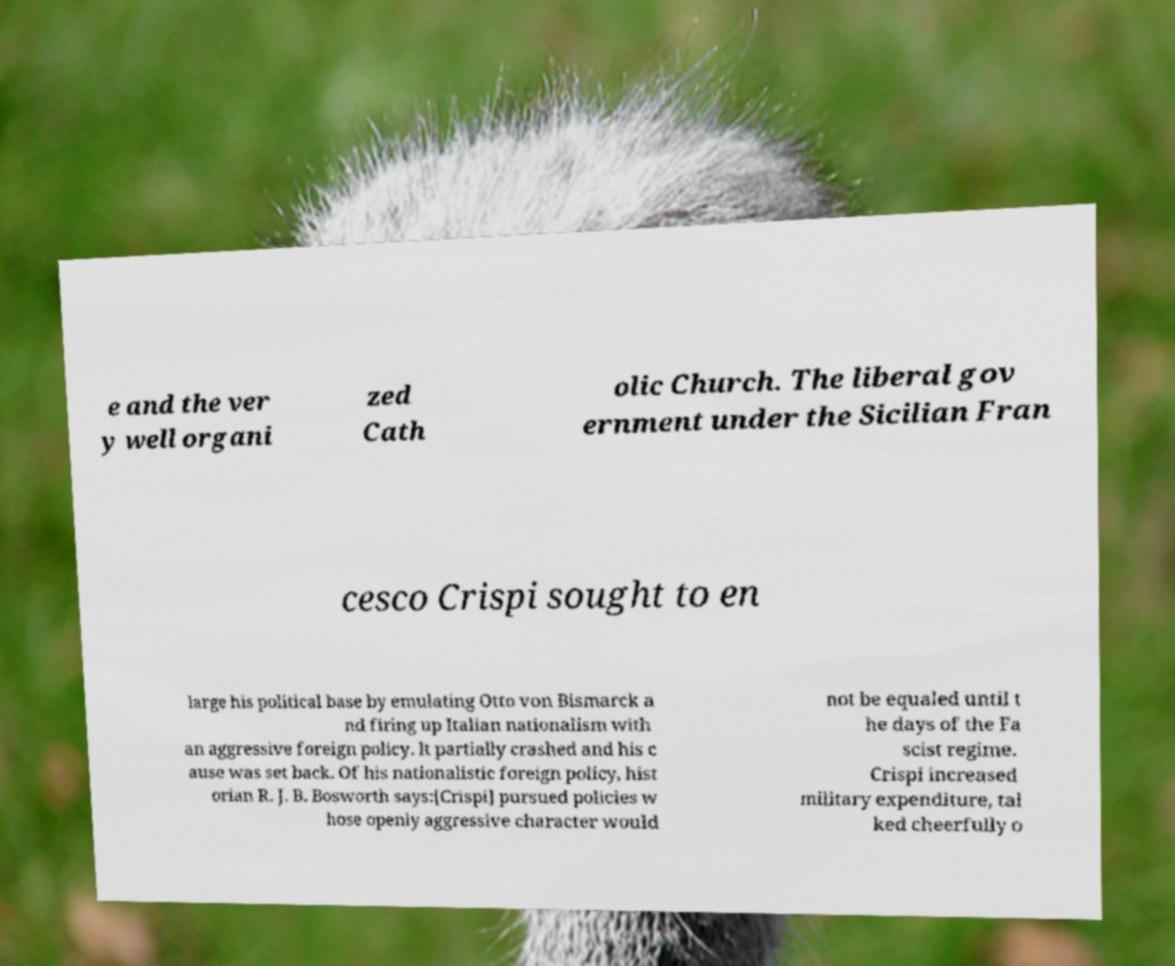Please read and relay the text visible in this image. What does it say? e and the ver y well organi zed Cath olic Church. The liberal gov ernment under the Sicilian Fran cesco Crispi sought to en large his political base by emulating Otto von Bismarck a nd firing up Italian nationalism with an aggressive foreign policy. It partially crashed and his c ause was set back. Of his nationalistic foreign policy, hist orian R. J. B. Bosworth says:[Crispi] pursued policies w hose openly aggressive character would not be equaled until t he days of the Fa scist regime. Crispi increased military expenditure, tal ked cheerfully o 